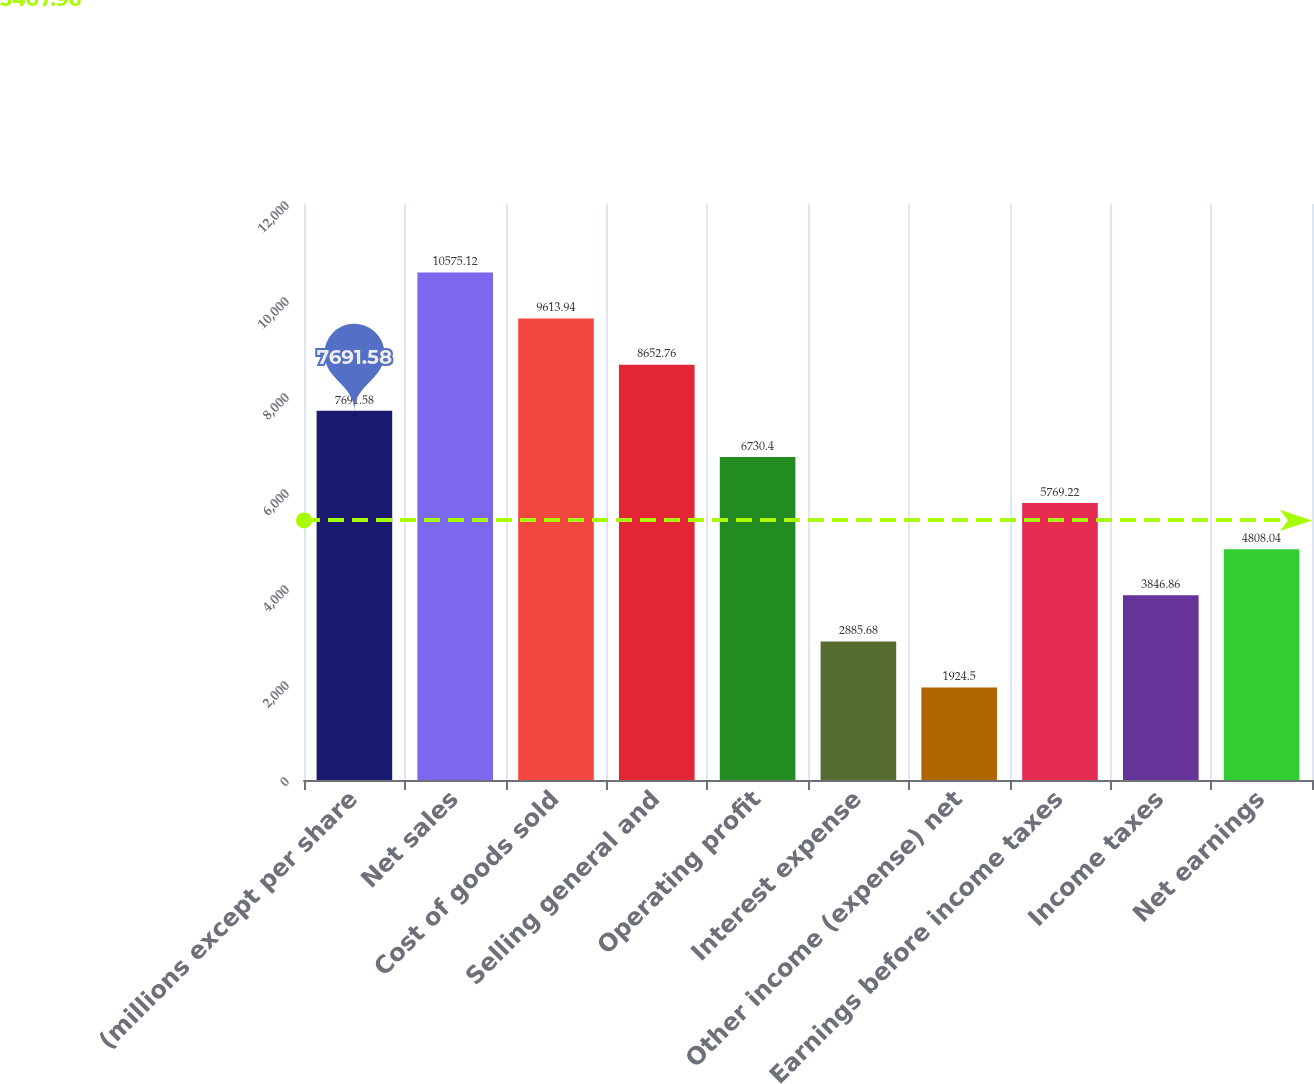<chart> <loc_0><loc_0><loc_500><loc_500><bar_chart><fcel>(millions except per share<fcel>Net sales<fcel>Cost of goods sold<fcel>Selling general and<fcel>Operating profit<fcel>Interest expense<fcel>Other income (expense) net<fcel>Earnings before income taxes<fcel>Income taxes<fcel>Net earnings<nl><fcel>7691.58<fcel>10575.1<fcel>9613.94<fcel>8652.76<fcel>6730.4<fcel>2885.68<fcel>1924.5<fcel>5769.22<fcel>3846.86<fcel>4808.04<nl></chart> 